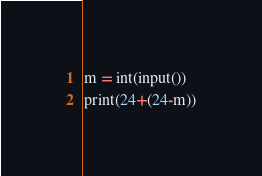<code> <loc_0><loc_0><loc_500><loc_500><_Python_>m = int(input())
print(24+(24-m))</code> 